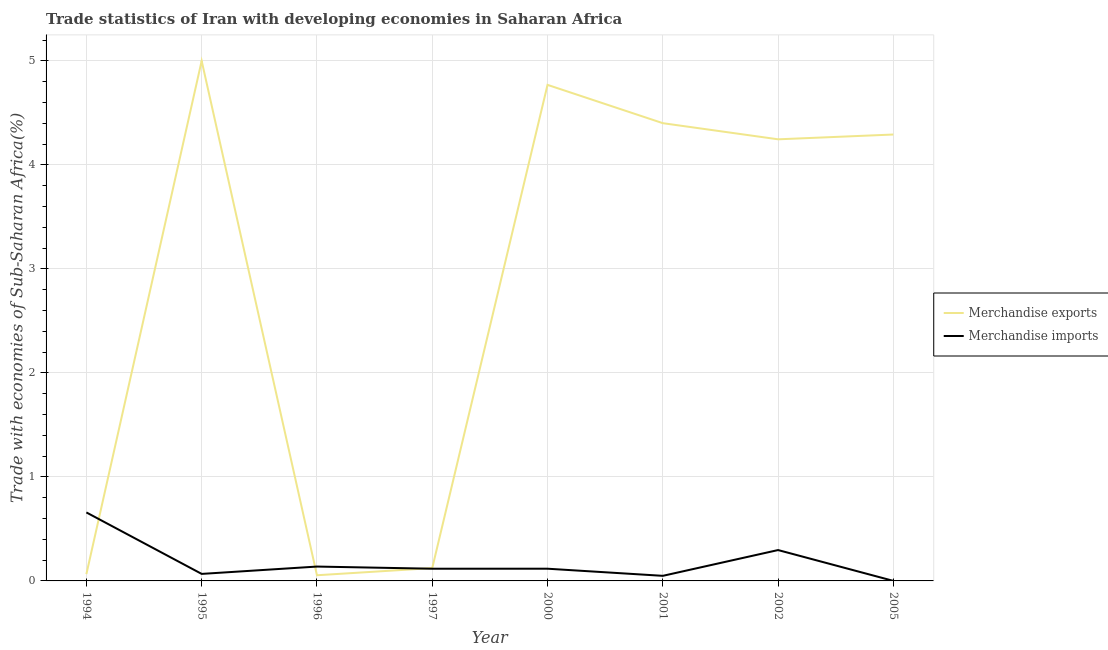How many different coloured lines are there?
Your response must be concise. 2. Does the line corresponding to merchandise exports intersect with the line corresponding to merchandise imports?
Keep it short and to the point. Yes. What is the merchandise imports in 1997?
Offer a terse response. 0.12. Across all years, what is the maximum merchandise imports?
Your answer should be compact. 0.66. Across all years, what is the minimum merchandise exports?
Your answer should be very brief. 0.05. In which year was the merchandise imports minimum?
Provide a short and direct response. 2005. What is the total merchandise imports in the graph?
Make the answer very short. 1.44. What is the difference between the merchandise exports in 1996 and that in 2002?
Offer a terse response. -4.19. What is the difference between the merchandise exports in 2000 and the merchandise imports in 2005?
Offer a terse response. 4.77. What is the average merchandise imports per year?
Make the answer very short. 0.18. In the year 2002, what is the difference between the merchandise imports and merchandise exports?
Your response must be concise. -3.95. In how many years, is the merchandise exports greater than 5 %?
Offer a terse response. 0. What is the ratio of the merchandise exports in 1997 to that in 2000?
Ensure brevity in your answer.  0.03. Is the difference between the merchandise imports in 1995 and 2002 greater than the difference between the merchandise exports in 1995 and 2002?
Your answer should be very brief. No. What is the difference between the highest and the second highest merchandise exports?
Offer a terse response. 0.23. What is the difference between the highest and the lowest merchandise exports?
Make the answer very short. 4.95. In how many years, is the merchandise exports greater than the average merchandise exports taken over all years?
Keep it short and to the point. 5. Is the merchandise imports strictly greater than the merchandise exports over the years?
Offer a terse response. No. Is the merchandise exports strictly less than the merchandise imports over the years?
Keep it short and to the point. No. What is the difference between two consecutive major ticks on the Y-axis?
Offer a very short reply. 1. Are the values on the major ticks of Y-axis written in scientific E-notation?
Make the answer very short. No. Does the graph contain any zero values?
Your answer should be very brief. No. Does the graph contain grids?
Offer a terse response. Yes. Where does the legend appear in the graph?
Make the answer very short. Center right. How many legend labels are there?
Offer a very short reply. 2. What is the title of the graph?
Give a very brief answer. Trade statistics of Iran with developing economies in Saharan Africa. What is the label or title of the X-axis?
Keep it short and to the point. Year. What is the label or title of the Y-axis?
Provide a short and direct response. Trade with economies of Sub-Saharan Africa(%). What is the Trade with economies of Sub-Saharan Africa(%) of Merchandise exports in 1994?
Ensure brevity in your answer.  0.07. What is the Trade with economies of Sub-Saharan Africa(%) in Merchandise imports in 1994?
Ensure brevity in your answer.  0.66. What is the Trade with economies of Sub-Saharan Africa(%) in Merchandise imports in 1995?
Make the answer very short. 0.07. What is the Trade with economies of Sub-Saharan Africa(%) in Merchandise exports in 1996?
Give a very brief answer. 0.05. What is the Trade with economies of Sub-Saharan Africa(%) of Merchandise imports in 1996?
Give a very brief answer. 0.14. What is the Trade with economies of Sub-Saharan Africa(%) of Merchandise exports in 1997?
Give a very brief answer. 0.12. What is the Trade with economies of Sub-Saharan Africa(%) of Merchandise imports in 1997?
Provide a short and direct response. 0.12. What is the Trade with economies of Sub-Saharan Africa(%) of Merchandise exports in 2000?
Keep it short and to the point. 4.77. What is the Trade with economies of Sub-Saharan Africa(%) of Merchandise imports in 2000?
Offer a very short reply. 0.12. What is the Trade with economies of Sub-Saharan Africa(%) in Merchandise exports in 2001?
Provide a succinct answer. 4.4. What is the Trade with economies of Sub-Saharan Africa(%) in Merchandise imports in 2001?
Offer a very short reply. 0.05. What is the Trade with economies of Sub-Saharan Africa(%) in Merchandise exports in 2002?
Your response must be concise. 4.25. What is the Trade with economies of Sub-Saharan Africa(%) in Merchandise imports in 2002?
Offer a very short reply. 0.3. What is the Trade with economies of Sub-Saharan Africa(%) of Merchandise exports in 2005?
Ensure brevity in your answer.  4.29. What is the Trade with economies of Sub-Saharan Africa(%) of Merchandise imports in 2005?
Provide a succinct answer. 0. Across all years, what is the maximum Trade with economies of Sub-Saharan Africa(%) of Merchandise exports?
Keep it short and to the point. 5. Across all years, what is the maximum Trade with economies of Sub-Saharan Africa(%) of Merchandise imports?
Your response must be concise. 0.66. Across all years, what is the minimum Trade with economies of Sub-Saharan Africa(%) of Merchandise exports?
Provide a short and direct response. 0.05. Across all years, what is the minimum Trade with economies of Sub-Saharan Africa(%) of Merchandise imports?
Your answer should be very brief. 0. What is the total Trade with economies of Sub-Saharan Africa(%) in Merchandise exports in the graph?
Give a very brief answer. 22.95. What is the total Trade with economies of Sub-Saharan Africa(%) in Merchandise imports in the graph?
Provide a succinct answer. 1.44. What is the difference between the Trade with economies of Sub-Saharan Africa(%) in Merchandise exports in 1994 and that in 1995?
Your answer should be compact. -4.93. What is the difference between the Trade with economies of Sub-Saharan Africa(%) of Merchandise imports in 1994 and that in 1995?
Make the answer very short. 0.59. What is the difference between the Trade with economies of Sub-Saharan Africa(%) of Merchandise exports in 1994 and that in 1996?
Ensure brevity in your answer.  0.01. What is the difference between the Trade with economies of Sub-Saharan Africa(%) in Merchandise imports in 1994 and that in 1996?
Provide a short and direct response. 0.52. What is the difference between the Trade with economies of Sub-Saharan Africa(%) of Merchandise exports in 1994 and that in 1997?
Offer a terse response. -0.06. What is the difference between the Trade with economies of Sub-Saharan Africa(%) of Merchandise imports in 1994 and that in 1997?
Offer a terse response. 0.54. What is the difference between the Trade with economies of Sub-Saharan Africa(%) in Merchandise exports in 1994 and that in 2000?
Provide a succinct answer. -4.7. What is the difference between the Trade with economies of Sub-Saharan Africa(%) of Merchandise imports in 1994 and that in 2000?
Provide a short and direct response. 0.54. What is the difference between the Trade with economies of Sub-Saharan Africa(%) of Merchandise exports in 1994 and that in 2001?
Give a very brief answer. -4.34. What is the difference between the Trade with economies of Sub-Saharan Africa(%) of Merchandise imports in 1994 and that in 2001?
Keep it short and to the point. 0.61. What is the difference between the Trade with economies of Sub-Saharan Africa(%) of Merchandise exports in 1994 and that in 2002?
Make the answer very short. -4.18. What is the difference between the Trade with economies of Sub-Saharan Africa(%) in Merchandise imports in 1994 and that in 2002?
Provide a short and direct response. 0.36. What is the difference between the Trade with economies of Sub-Saharan Africa(%) of Merchandise exports in 1994 and that in 2005?
Your answer should be compact. -4.23. What is the difference between the Trade with economies of Sub-Saharan Africa(%) of Merchandise imports in 1994 and that in 2005?
Offer a terse response. 0.66. What is the difference between the Trade with economies of Sub-Saharan Africa(%) of Merchandise exports in 1995 and that in 1996?
Make the answer very short. 4.95. What is the difference between the Trade with economies of Sub-Saharan Africa(%) of Merchandise imports in 1995 and that in 1996?
Your answer should be compact. -0.07. What is the difference between the Trade with economies of Sub-Saharan Africa(%) in Merchandise exports in 1995 and that in 1997?
Give a very brief answer. 4.88. What is the difference between the Trade with economies of Sub-Saharan Africa(%) in Merchandise imports in 1995 and that in 1997?
Your response must be concise. -0.05. What is the difference between the Trade with economies of Sub-Saharan Africa(%) in Merchandise exports in 1995 and that in 2000?
Your answer should be very brief. 0.23. What is the difference between the Trade with economies of Sub-Saharan Africa(%) of Merchandise imports in 1995 and that in 2000?
Give a very brief answer. -0.05. What is the difference between the Trade with economies of Sub-Saharan Africa(%) of Merchandise exports in 1995 and that in 2001?
Keep it short and to the point. 0.6. What is the difference between the Trade with economies of Sub-Saharan Africa(%) of Merchandise imports in 1995 and that in 2001?
Your response must be concise. 0.02. What is the difference between the Trade with economies of Sub-Saharan Africa(%) of Merchandise exports in 1995 and that in 2002?
Keep it short and to the point. 0.75. What is the difference between the Trade with economies of Sub-Saharan Africa(%) in Merchandise imports in 1995 and that in 2002?
Your answer should be very brief. -0.23. What is the difference between the Trade with economies of Sub-Saharan Africa(%) of Merchandise exports in 1995 and that in 2005?
Provide a succinct answer. 0.71. What is the difference between the Trade with economies of Sub-Saharan Africa(%) in Merchandise imports in 1995 and that in 2005?
Your answer should be compact. 0.07. What is the difference between the Trade with economies of Sub-Saharan Africa(%) of Merchandise exports in 1996 and that in 1997?
Your response must be concise. -0.07. What is the difference between the Trade with economies of Sub-Saharan Africa(%) in Merchandise imports in 1996 and that in 1997?
Your answer should be compact. 0.02. What is the difference between the Trade with economies of Sub-Saharan Africa(%) of Merchandise exports in 1996 and that in 2000?
Ensure brevity in your answer.  -4.71. What is the difference between the Trade with economies of Sub-Saharan Africa(%) in Merchandise imports in 1996 and that in 2000?
Offer a terse response. 0.02. What is the difference between the Trade with economies of Sub-Saharan Africa(%) in Merchandise exports in 1996 and that in 2001?
Give a very brief answer. -4.35. What is the difference between the Trade with economies of Sub-Saharan Africa(%) in Merchandise imports in 1996 and that in 2001?
Give a very brief answer. 0.09. What is the difference between the Trade with economies of Sub-Saharan Africa(%) of Merchandise exports in 1996 and that in 2002?
Provide a short and direct response. -4.19. What is the difference between the Trade with economies of Sub-Saharan Africa(%) in Merchandise imports in 1996 and that in 2002?
Make the answer very short. -0.16. What is the difference between the Trade with economies of Sub-Saharan Africa(%) of Merchandise exports in 1996 and that in 2005?
Your answer should be very brief. -4.24. What is the difference between the Trade with economies of Sub-Saharan Africa(%) in Merchandise imports in 1996 and that in 2005?
Provide a succinct answer. 0.14. What is the difference between the Trade with economies of Sub-Saharan Africa(%) of Merchandise exports in 1997 and that in 2000?
Your response must be concise. -4.65. What is the difference between the Trade with economies of Sub-Saharan Africa(%) in Merchandise imports in 1997 and that in 2000?
Your answer should be very brief. -0. What is the difference between the Trade with economies of Sub-Saharan Africa(%) in Merchandise exports in 1997 and that in 2001?
Make the answer very short. -4.28. What is the difference between the Trade with economies of Sub-Saharan Africa(%) of Merchandise imports in 1997 and that in 2001?
Your answer should be very brief. 0.07. What is the difference between the Trade with economies of Sub-Saharan Africa(%) of Merchandise exports in 1997 and that in 2002?
Ensure brevity in your answer.  -4.12. What is the difference between the Trade with economies of Sub-Saharan Africa(%) in Merchandise imports in 1997 and that in 2002?
Ensure brevity in your answer.  -0.18. What is the difference between the Trade with economies of Sub-Saharan Africa(%) in Merchandise exports in 1997 and that in 2005?
Ensure brevity in your answer.  -4.17. What is the difference between the Trade with economies of Sub-Saharan Africa(%) in Merchandise imports in 1997 and that in 2005?
Make the answer very short. 0.12. What is the difference between the Trade with economies of Sub-Saharan Africa(%) in Merchandise exports in 2000 and that in 2001?
Your answer should be compact. 0.37. What is the difference between the Trade with economies of Sub-Saharan Africa(%) of Merchandise imports in 2000 and that in 2001?
Offer a very short reply. 0.07. What is the difference between the Trade with economies of Sub-Saharan Africa(%) of Merchandise exports in 2000 and that in 2002?
Your answer should be compact. 0.52. What is the difference between the Trade with economies of Sub-Saharan Africa(%) in Merchandise imports in 2000 and that in 2002?
Make the answer very short. -0.18. What is the difference between the Trade with economies of Sub-Saharan Africa(%) in Merchandise exports in 2000 and that in 2005?
Keep it short and to the point. 0.48. What is the difference between the Trade with economies of Sub-Saharan Africa(%) in Merchandise imports in 2000 and that in 2005?
Make the answer very short. 0.12. What is the difference between the Trade with economies of Sub-Saharan Africa(%) of Merchandise exports in 2001 and that in 2002?
Offer a terse response. 0.16. What is the difference between the Trade with economies of Sub-Saharan Africa(%) of Merchandise imports in 2001 and that in 2002?
Provide a short and direct response. -0.25. What is the difference between the Trade with economies of Sub-Saharan Africa(%) of Merchandise exports in 2001 and that in 2005?
Ensure brevity in your answer.  0.11. What is the difference between the Trade with economies of Sub-Saharan Africa(%) of Merchandise imports in 2001 and that in 2005?
Offer a very short reply. 0.05. What is the difference between the Trade with economies of Sub-Saharan Africa(%) of Merchandise exports in 2002 and that in 2005?
Make the answer very short. -0.05. What is the difference between the Trade with economies of Sub-Saharan Africa(%) in Merchandise imports in 2002 and that in 2005?
Your answer should be compact. 0.3. What is the difference between the Trade with economies of Sub-Saharan Africa(%) in Merchandise exports in 1994 and the Trade with economies of Sub-Saharan Africa(%) in Merchandise imports in 1995?
Offer a very short reply. -0. What is the difference between the Trade with economies of Sub-Saharan Africa(%) in Merchandise exports in 1994 and the Trade with economies of Sub-Saharan Africa(%) in Merchandise imports in 1996?
Ensure brevity in your answer.  -0.07. What is the difference between the Trade with economies of Sub-Saharan Africa(%) in Merchandise exports in 1994 and the Trade with economies of Sub-Saharan Africa(%) in Merchandise imports in 1997?
Your answer should be compact. -0.05. What is the difference between the Trade with economies of Sub-Saharan Africa(%) of Merchandise exports in 1994 and the Trade with economies of Sub-Saharan Africa(%) of Merchandise imports in 2000?
Make the answer very short. -0.05. What is the difference between the Trade with economies of Sub-Saharan Africa(%) in Merchandise exports in 1994 and the Trade with economies of Sub-Saharan Africa(%) in Merchandise imports in 2001?
Offer a terse response. 0.02. What is the difference between the Trade with economies of Sub-Saharan Africa(%) of Merchandise exports in 1994 and the Trade with economies of Sub-Saharan Africa(%) of Merchandise imports in 2002?
Provide a succinct answer. -0.23. What is the difference between the Trade with economies of Sub-Saharan Africa(%) in Merchandise exports in 1994 and the Trade with economies of Sub-Saharan Africa(%) in Merchandise imports in 2005?
Your answer should be compact. 0.07. What is the difference between the Trade with economies of Sub-Saharan Africa(%) of Merchandise exports in 1995 and the Trade with economies of Sub-Saharan Africa(%) of Merchandise imports in 1996?
Keep it short and to the point. 4.86. What is the difference between the Trade with economies of Sub-Saharan Africa(%) in Merchandise exports in 1995 and the Trade with economies of Sub-Saharan Africa(%) in Merchandise imports in 1997?
Make the answer very short. 4.88. What is the difference between the Trade with economies of Sub-Saharan Africa(%) of Merchandise exports in 1995 and the Trade with economies of Sub-Saharan Africa(%) of Merchandise imports in 2000?
Keep it short and to the point. 4.88. What is the difference between the Trade with economies of Sub-Saharan Africa(%) of Merchandise exports in 1995 and the Trade with economies of Sub-Saharan Africa(%) of Merchandise imports in 2001?
Give a very brief answer. 4.95. What is the difference between the Trade with economies of Sub-Saharan Africa(%) of Merchandise exports in 1995 and the Trade with economies of Sub-Saharan Africa(%) of Merchandise imports in 2002?
Your answer should be compact. 4.7. What is the difference between the Trade with economies of Sub-Saharan Africa(%) in Merchandise exports in 1995 and the Trade with economies of Sub-Saharan Africa(%) in Merchandise imports in 2005?
Keep it short and to the point. 5. What is the difference between the Trade with economies of Sub-Saharan Africa(%) of Merchandise exports in 1996 and the Trade with economies of Sub-Saharan Africa(%) of Merchandise imports in 1997?
Provide a succinct answer. -0.06. What is the difference between the Trade with economies of Sub-Saharan Africa(%) in Merchandise exports in 1996 and the Trade with economies of Sub-Saharan Africa(%) in Merchandise imports in 2000?
Your answer should be very brief. -0.06. What is the difference between the Trade with economies of Sub-Saharan Africa(%) in Merchandise exports in 1996 and the Trade with economies of Sub-Saharan Africa(%) in Merchandise imports in 2001?
Your response must be concise. 0.01. What is the difference between the Trade with economies of Sub-Saharan Africa(%) in Merchandise exports in 1996 and the Trade with economies of Sub-Saharan Africa(%) in Merchandise imports in 2002?
Your answer should be very brief. -0.24. What is the difference between the Trade with economies of Sub-Saharan Africa(%) of Merchandise exports in 1996 and the Trade with economies of Sub-Saharan Africa(%) of Merchandise imports in 2005?
Your answer should be very brief. 0.05. What is the difference between the Trade with economies of Sub-Saharan Africa(%) of Merchandise exports in 1997 and the Trade with economies of Sub-Saharan Africa(%) of Merchandise imports in 2000?
Your answer should be compact. 0.01. What is the difference between the Trade with economies of Sub-Saharan Africa(%) of Merchandise exports in 1997 and the Trade with economies of Sub-Saharan Africa(%) of Merchandise imports in 2001?
Offer a very short reply. 0.07. What is the difference between the Trade with economies of Sub-Saharan Africa(%) of Merchandise exports in 1997 and the Trade with economies of Sub-Saharan Africa(%) of Merchandise imports in 2002?
Ensure brevity in your answer.  -0.17. What is the difference between the Trade with economies of Sub-Saharan Africa(%) of Merchandise exports in 1997 and the Trade with economies of Sub-Saharan Africa(%) of Merchandise imports in 2005?
Offer a terse response. 0.12. What is the difference between the Trade with economies of Sub-Saharan Africa(%) in Merchandise exports in 2000 and the Trade with economies of Sub-Saharan Africa(%) in Merchandise imports in 2001?
Keep it short and to the point. 4.72. What is the difference between the Trade with economies of Sub-Saharan Africa(%) of Merchandise exports in 2000 and the Trade with economies of Sub-Saharan Africa(%) of Merchandise imports in 2002?
Ensure brevity in your answer.  4.47. What is the difference between the Trade with economies of Sub-Saharan Africa(%) of Merchandise exports in 2000 and the Trade with economies of Sub-Saharan Africa(%) of Merchandise imports in 2005?
Offer a very short reply. 4.77. What is the difference between the Trade with economies of Sub-Saharan Africa(%) of Merchandise exports in 2001 and the Trade with economies of Sub-Saharan Africa(%) of Merchandise imports in 2002?
Offer a terse response. 4.1. What is the difference between the Trade with economies of Sub-Saharan Africa(%) in Merchandise exports in 2001 and the Trade with economies of Sub-Saharan Africa(%) in Merchandise imports in 2005?
Make the answer very short. 4.4. What is the difference between the Trade with economies of Sub-Saharan Africa(%) of Merchandise exports in 2002 and the Trade with economies of Sub-Saharan Africa(%) of Merchandise imports in 2005?
Provide a succinct answer. 4.25. What is the average Trade with economies of Sub-Saharan Africa(%) in Merchandise exports per year?
Provide a short and direct response. 2.87. What is the average Trade with economies of Sub-Saharan Africa(%) in Merchandise imports per year?
Offer a terse response. 0.18. In the year 1994, what is the difference between the Trade with economies of Sub-Saharan Africa(%) of Merchandise exports and Trade with economies of Sub-Saharan Africa(%) of Merchandise imports?
Offer a very short reply. -0.59. In the year 1995, what is the difference between the Trade with economies of Sub-Saharan Africa(%) of Merchandise exports and Trade with economies of Sub-Saharan Africa(%) of Merchandise imports?
Offer a terse response. 4.93. In the year 1996, what is the difference between the Trade with economies of Sub-Saharan Africa(%) of Merchandise exports and Trade with economies of Sub-Saharan Africa(%) of Merchandise imports?
Keep it short and to the point. -0.08. In the year 1997, what is the difference between the Trade with economies of Sub-Saharan Africa(%) in Merchandise exports and Trade with economies of Sub-Saharan Africa(%) in Merchandise imports?
Offer a very short reply. 0.01. In the year 2000, what is the difference between the Trade with economies of Sub-Saharan Africa(%) in Merchandise exports and Trade with economies of Sub-Saharan Africa(%) in Merchandise imports?
Offer a very short reply. 4.65. In the year 2001, what is the difference between the Trade with economies of Sub-Saharan Africa(%) in Merchandise exports and Trade with economies of Sub-Saharan Africa(%) in Merchandise imports?
Provide a succinct answer. 4.35. In the year 2002, what is the difference between the Trade with economies of Sub-Saharan Africa(%) in Merchandise exports and Trade with economies of Sub-Saharan Africa(%) in Merchandise imports?
Ensure brevity in your answer.  3.95. In the year 2005, what is the difference between the Trade with economies of Sub-Saharan Africa(%) of Merchandise exports and Trade with economies of Sub-Saharan Africa(%) of Merchandise imports?
Your answer should be very brief. 4.29. What is the ratio of the Trade with economies of Sub-Saharan Africa(%) of Merchandise exports in 1994 to that in 1995?
Provide a succinct answer. 0.01. What is the ratio of the Trade with economies of Sub-Saharan Africa(%) of Merchandise imports in 1994 to that in 1995?
Make the answer very short. 9.75. What is the ratio of the Trade with economies of Sub-Saharan Africa(%) in Merchandise exports in 1994 to that in 1996?
Provide a succinct answer. 1.2. What is the ratio of the Trade with economies of Sub-Saharan Africa(%) of Merchandise imports in 1994 to that in 1996?
Offer a terse response. 4.77. What is the ratio of the Trade with economies of Sub-Saharan Africa(%) of Merchandise exports in 1994 to that in 1997?
Give a very brief answer. 0.53. What is the ratio of the Trade with economies of Sub-Saharan Africa(%) of Merchandise imports in 1994 to that in 1997?
Offer a very short reply. 5.61. What is the ratio of the Trade with economies of Sub-Saharan Africa(%) of Merchandise exports in 1994 to that in 2000?
Provide a short and direct response. 0.01. What is the ratio of the Trade with economies of Sub-Saharan Africa(%) in Merchandise imports in 1994 to that in 2000?
Provide a short and direct response. 5.61. What is the ratio of the Trade with economies of Sub-Saharan Africa(%) in Merchandise exports in 1994 to that in 2001?
Your answer should be very brief. 0.01. What is the ratio of the Trade with economies of Sub-Saharan Africa(%) of Merchandise imports in 1994 to that in 2001?
Make the answer very short. 13.45. What is the ratio of the Trade with economies of Sub-Saharan Africa(%) of Merchandise exports in 1994 to that in 2002?
Provide a short and direct response. 0.02. What is the ratio of the Trade with economies of Sub-Saharan Africa(%) in Merchandise imports in 1994 to that in 2002?
Offer a very short reply. 2.22. What is the ratio of the Trade with economies of Sub-Saharan Africa(%) of Merchandise exports in 1994 to that in 2005?
Keep it short and to the point. 0.02. What is the ratio of the Trade with economies of Sub-Saharan Africa(%) in Merchandise imports in 1994 to that in 2005?
Your answer should be very brief. 1967.02. What is the ratio of the Trade with economies of Sub-Saharan Africa(%) of Merchandise exports in 1995 to that in 1996?
Your response must be concise. 91.77. What is the ratio of the Trade with economies of Sub-Saharan Africa(%) in Merchandise imports in 1995 to that in 1996?
Offer a terse response. 0.49. What is the ratio of the Trade with economies of Sub-Saharan Africa(%) in Merchandise exports in 1995 to that in 1997?
Provide a succinct answer. 40.49. What is the ratio of the Trade with economies of Sub-Saharan Africa(%) in Merchandise imports in 1995 to that in 1997?
Ensure brevity in your answer.  0.58. What is the ratio of the Trade with economies of Sub-Saharan Africa(%) of Merchandise exports in 1995 to that in 2000?
Give a very brief answer. 1.05. What is the ratio of the Trade with economies of Sub-Saharan Africa(%) in Merchandise imports in 1995 to that in 2000?
Offer a very short reply. 0.58. What is the ratio of the Trade with economies of Sub-Saharan Africa(%) of Merchandise exports in 1995 to that in 2001?
Your answer should be compact. 1.14. What is the ratio of the Trade with economies of Sub-Saharan Africa(%) in Merchandise imports in 1995 to that in 2001?
Ensure brevity in your answer.  1.38. What is the ratio of the Trade with economies of Sub-Saharan Africa(%) in Merchandise exports in 1995 to that in 2002?
Give a very brief answer. 1.18. What is the ratio of the Trade with economies of Sub-Saharan Africa(%) of Merchandise imports in 1995 to that in 2002?
Your answer should be compact. 0.23. What is the ratio of the Trade with economies of Sub-Saharan Africa(%) of Merchandise exports in 1995 to that in 2005?
Ensure brevity in your answer.  1.17. What is the ratio of the Trade with economies of Sub-Saharan Africa(%) of Merchandise imports in 1995 to that in 2005?
Ensure brevity in your answer.  201.74. What is the ratio of the Trade with economies of Sub-Saharan Africa(%) of Merchandise exports in 1996 to that in 1997?
Your answer should be very brief. 0.44. What is the ratio of the Trade with economies of Sub-Saharan Africa(%) of Merchandise imports in 1996 to that in 1997?
Provide a succinct answer. 1.18. What is the ratio of the Trade with economies of Sub-Saharan Africa(%) in Merchandise exports in 1996 to that in 2000?
Offer a terse response. 0.01. What is the ratio of the Trade with economies of Sub-Saharan Africa(%) of Merchandise imports in 1996 to that in 2000?
Make the answer very short. 1.18. What is the ratio of the Trade with economies of Sub-Saharan Africa(%) of Merchandise exports in 1996 to that in 2001?
Offer a very short reply. 0.01. What is the ratio of the Trade with economies of Sub-Saharan Africa(%) in Merchandise imports in 1996 to that in 2001?
Give a very brief answer. 2.82. What is the ratio of the Trade with economies of Sub-Saharan Africa(%) of Merchandise exports in 1996 to that in 2002?
Provide a succinct answer. 0.01. What is the ratio of the Trade with economies of Sub-Saharan Africa(%) of Merchandise imports in 1996 to that in 2002?
Give a very brief answer. 0.47. What is the ratio of the Trade with economies of Sub-Saharan Africa(%) in Merchandise exports in 1996 to that in 2005?
Provide a short and direct response. 0.01. What is the ratio of the Trade with economies of Sub-Saharan Africa(%) of Merchandise imports in 1996 to that in 2005?
Ensure brevity in your answer.  412.5. What is the ratio of the Trade with economies of Sub-Saharan Africa(%) of Merchandise exports in 1997 to that in 2000?
Ensure brevity in your answer.  0.03. What is the ratio of the Trade with economies of Sub-Saharan Africa(%) in Merchandise imports in 1997 to that in 2000?
Keep it short and to the point. 1. What is the ratio of the Trade with economies of Sub-Saharan Africa(%) of Merchandise exports in 1997 to that in 2001?
Ensure brevity in your answer.  0.03. What is the ratio of the Trade with economies of Sub-Saharan Africa(%) of Merchandise imports in 1997 to that in 2001?
Give a very brief answer. 2.4. What is the ratio of the Trade with economies of Sub-Saharan Africa(%) of Merchandise exports in 1997 to that in 2002?
Provide a short and direct response. 0.03. What is the ratio of the Trade with economies of Sub-Saharan Africa(%) of Merchandise imports in 1997 to that in 2002?
Offer a very short reply. 0.4. What is the ratio of the Trade with economies of Sub-Saharan Africa(%) in Merchandise exports in 1997 to that in 2005?
Provide a succinct answer. 0.03. What is the ratio of the Trade with economies of Sub-Saharan Africa(%) in Merchandise imports in 1997 to that in 2005?
Your answer should be very brief. 350.35. What is the ratio of the Trade with economies of Sub-Saharan Africa(%) in Merchandise exports in 2000 to that in 2001?
Make the answer very short. 1.08. What is the ratio of the Trade with economies of Sub-Saharan Africa(%) of Merchandise imports in 2000 to that in 2001?
Keep it short and to the point. 2.4. What is the ratio of the Trade with economies of Sub-Saharan Africa(%) in Merchandise exports in 2000 to that in 2002?
Make the answer very short. 1.12. What is the ratio of the Trade with economies of Sub-Saharan Africa(%) in Merchandise imports in 2000 to that in 2002?
Your answer should be compact. 0.4. What is the ratio of the Trade with economies of Sub-Saharan Africa(%) of Merchandise exports in 2000 to that in 2005?
Your response must be concise. 1.11. What is the ratio of the Trade with economies of Sub-Saharan Africa(%) of Merchandise imports in 2000 to that in 2005?
Make the answer very short. 350.7. What is the ratio of the Trade with economies of Sub-Saharan Africa(%) in Merchandise exports in 2001 to that in 2002?
Offer a very short reply. 1.04. What is the ratio of the Trade with economies of Sub-Saharan Africa(%) in Merchandise imports in 2001 to that in 2002?
Make the answer very short. 0.17. What is the ratio of the Trade with economies of Sub-Saharan Africa(%) of Merchandise exports in 2001 to that in 2005?
Keep it short and to the point. 1.03. What is the ratio of the Trade with economies of Sub-Saharan Africa(%) in Merchandise imports in 2001 to that in 2005?
Your answer should be very brief. 146.22. What is the ratio of the Trade with economies of Sub-Saharan Africa(%) of Merchandise exports in 2002 to that in 2005?
Give a very brief answer. 0.99. What is the ratio of the Trade with economies of Sub-Saharan Africa(%) in Merchandise imports in 2002 to that in 2005?
Your answer should be compact. 886.28. What is the difference between the highest and the second highest Trade with economies of Sub-Saharan Africa(%) of Merchandise exports?
Your answer should be very brief. 0.23. What is the difference between the highest and the second highest Trade with economies of Sub-Saharan Africa(%) of Merchandise imports?
Your answer should be compact. 0.36. What is the difference between the highest and the lowest Trade with economies of Sub-Saharan Africa(%) of Merchandise exports?
Keep it short and to the point. 4.95. What is the difference between the highest and the lowest Trade with economies of Sub-Saharan Africa(%) in Merchandise imports?
Make the answer very short. 0.66. 